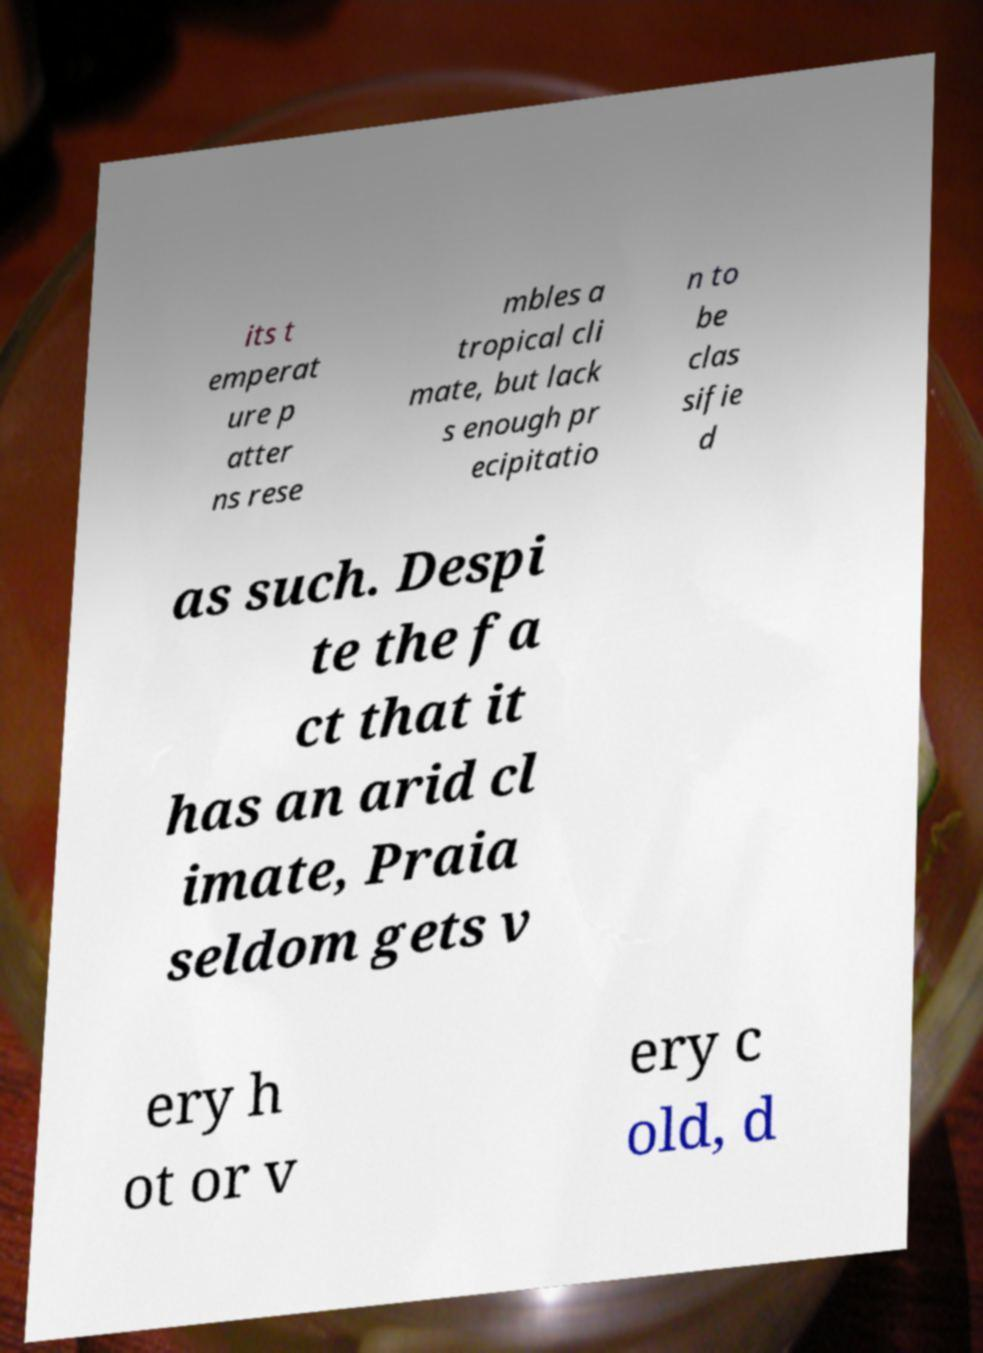I need the written content from this picture converted into text. Can you do that? its t emperat ure p atter ns rese mbles a tropical cli mate, but lack s enough pr ecipitatio n to be clas sifie d as such. Despi te the fa ct that it has an arid cl imate, Praia seldom gets v ery h ot or v ery c old, d 